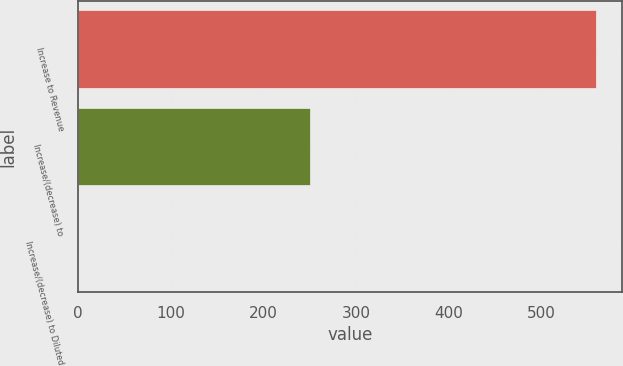Convert chart to OTSL. <chart><loc_0><loc_0><loc_500><loc_500><bar_chart><fcel>Increase to Revenue<fcel>Increase/(decrease) to<fcel>Increase/(decrease) to Diluted<nl><fcel>559<fcel>250<fcel>0.34<nl></chart> 